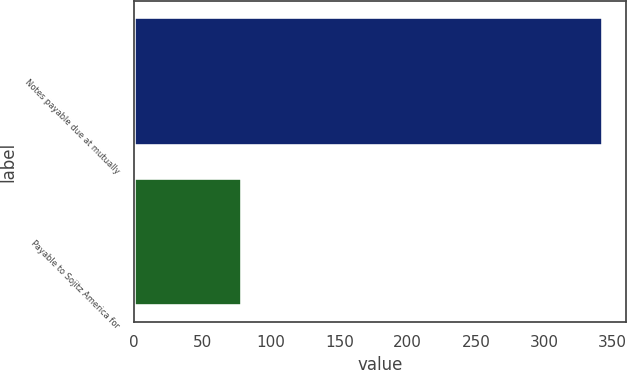Convert chart. <chart><loc_0><loc_0><loc_500><loc_500><bar_chart><fcel>Notes payable due at mutually<fcel>Payable to Sojitz America for<nl><fcel>342.9<fcel>78.5<nl></chart> 